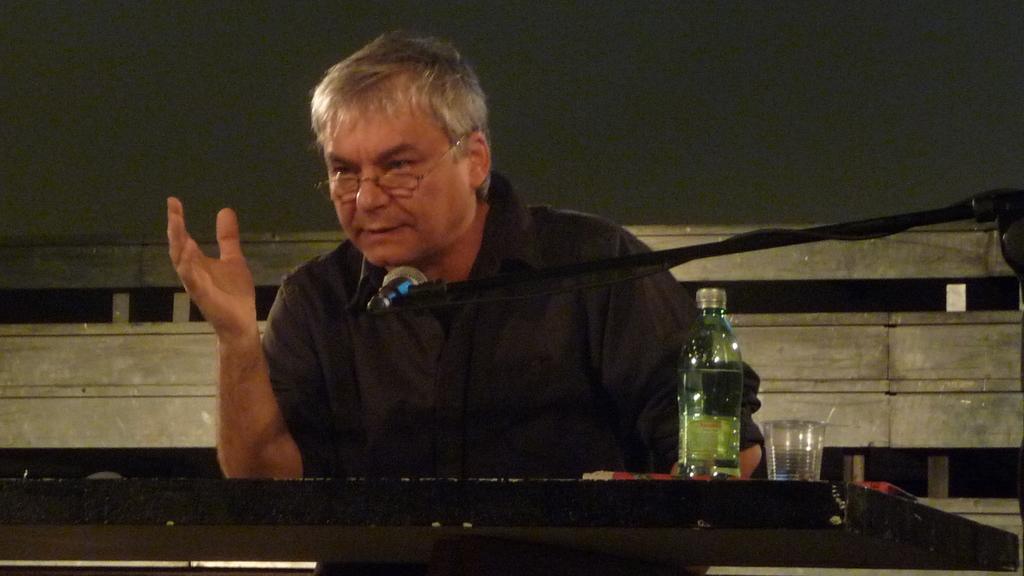In one or two sentences, can you explain what this image depicts? This image is taken indoors. In the background there is a wall. At the top of the image there is a roof. In the middle of the image there is a man and there is a podium with a bottle, a glass and a mic. 